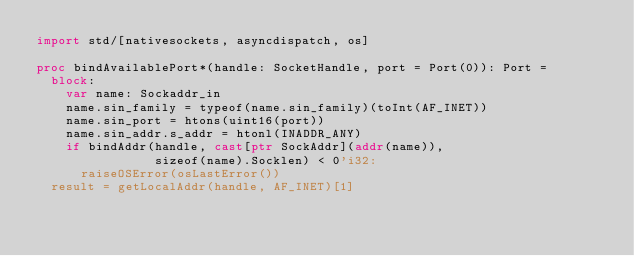Convert code to text. <code><loc_0><loc_0><loc_500><loc_500><_Nim_>import std/[nativesockets, asyncdispatch, os]

proc bindAvailablePort*(handle: SocketHandle, port = Port(0)): Port =
  block:
    var name: Sockaddr_in
    name.sin_family = typeof(name.sin_family)(toInt(AF_INET))
    name.sin_port = htons(uint16(port))
    name.sin_addr.s_addr = htonl(INADDR_ANY)
    if bindAddr(handle, cast[ptr SockAddr](addr(name)),
                sizeof(name).Socklen) < 0'i32:
      raiseOSError(osLastError())
  result = getLocalAddr(handle, AF_INET)[1]
</code> 